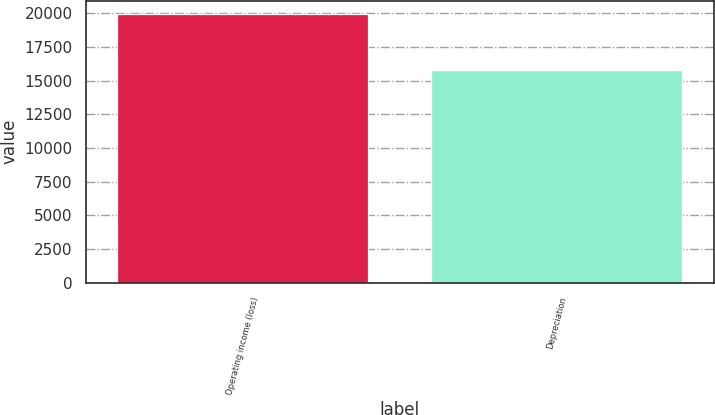Convert chart. <chart><loc_0><loc_0><loc_500><loc_500><bar_chart><fcel>Operating income (loss)<fcel>Depreciation<nl><fcel>19965<fcel>15766<nl></chart> 